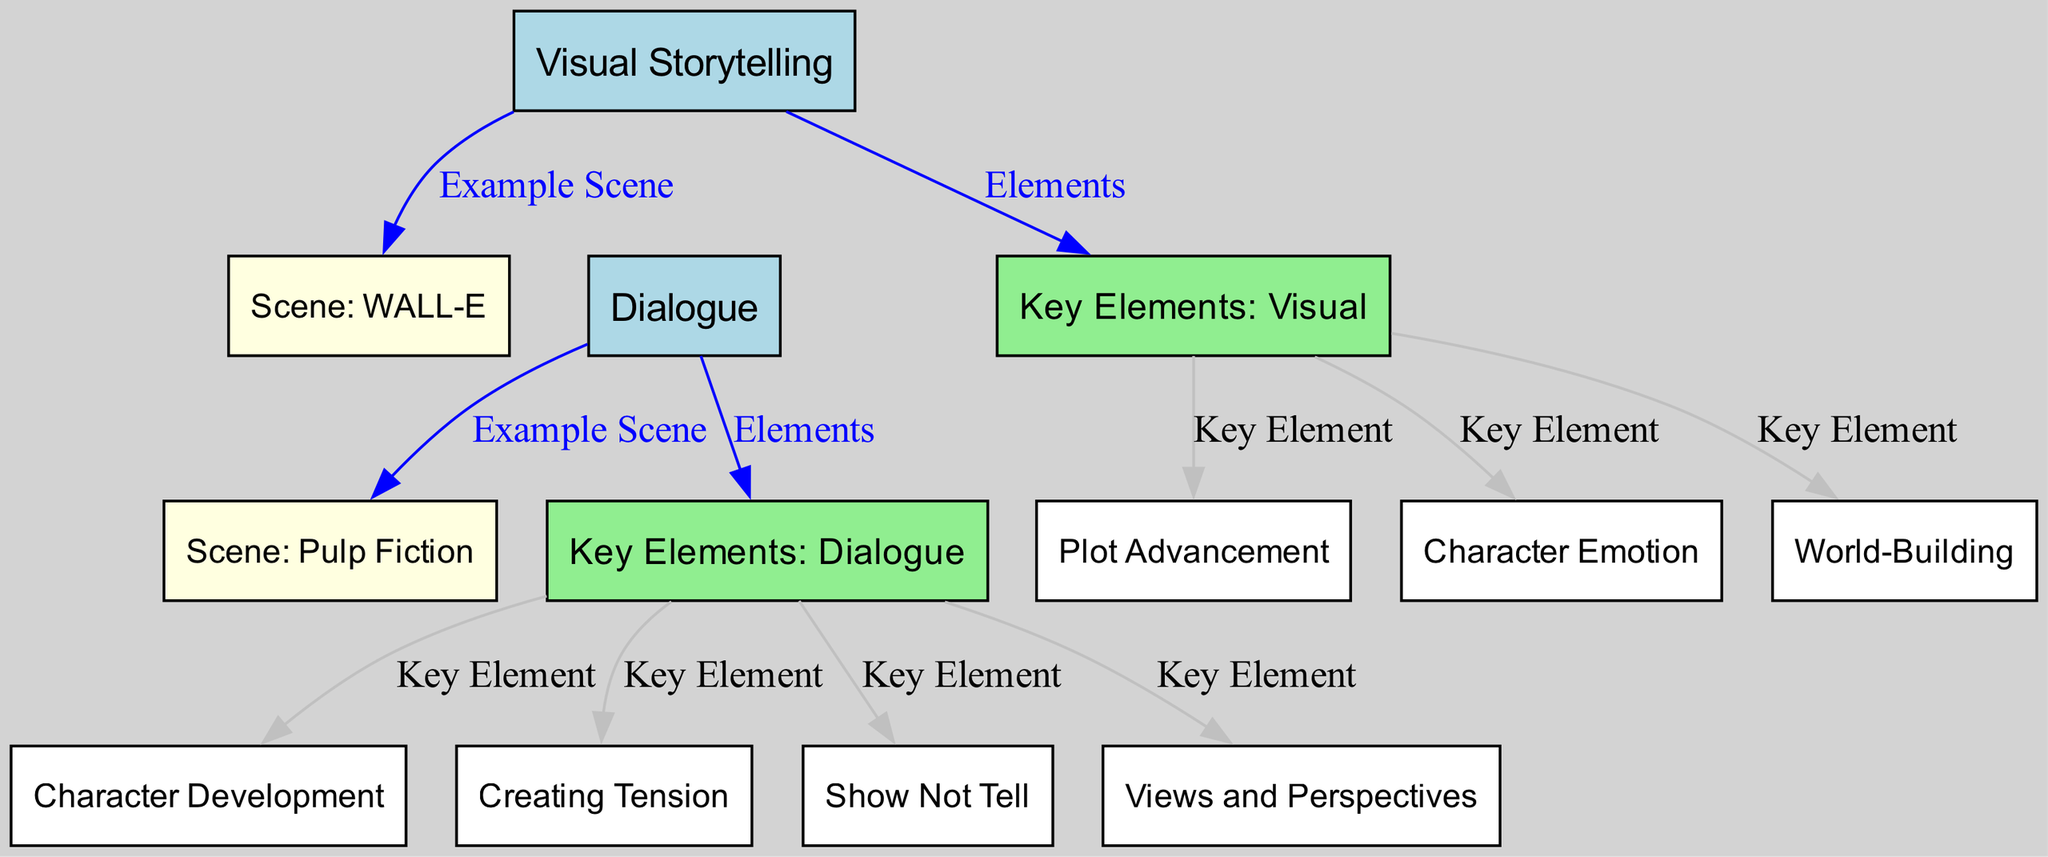what is the main topic of the diagram? The title "Dialogue vs. Visual Storytelling: Effective Use in Screenwriting" indicates the main topic is comparing the use of dialogue and visual storytelling in screenwriting.
Answer: Dialogue vs. Visual Storytelling: Effective Use in Screenwriting how many nodes are there in the diagram? By counting each unique labeled item in the 'nodes' section of the data, we find that there are a total of 13 nodes.
Answer: 13 which scene is associated with visual storytelling? The edge connecting the 'Visual Storytelling' node to the 'Scene: WALL-E' node indicates that WALL-E is an example of visual storytelling in the diagram.
Answer: Scene: WALL-E which scene is associated with dialogue? The edge from the 'Dialogue' node to the 'Scene: Pulp Fiction' node indicates that Pulp Fiction exemplifies the use of dialogue in storytelling.
Answer: Scene: Pulp Fiction what are the three key elements of visual storytelling? The diagram lists 'Character Emotion', 'World-Building', and 'Plot Advancement' as the three key elements connected to the 'Visual' node.
Answer: Character Emotion, World-Building, Plot Advancement what are the four key elements of dialogue? The edges leading from the 'Dialogue' node connect to 'Character Development', 'Creating Tension', 'Show Not Tell', and 'Views and Perspectives', indicating these are the key elements of dialogue.
Answer: Character Development, Creating Tension, Show Not Tell, Views and Perspectives what is the relationship between visual storytelling and character emotion? The edge labeled 'Key Element' connecting 'Visual Storytelling' to 'Character Emotion' suggests that character emotion is an element defined by visual storytelling, reinforcing how visuals can depict character feelings without dialogue.
Answer: Key Element which node connects directly to both visual storytelling and dialogue? The diagram outlines that there is no direct connection from 'Visual Storytelling' to 'Dialogue', but they are linked through the 'Scene: WALL-E' and 'Scene: Pulp Fiction' nodes respectively, which exemplify each method.
Answer: None how does visual storytelling affect plot advancement? The connecting edge labeled 'Key Element' from 'Visual' to 'Plot Advancement' signifies that visual storytelling can effectively push the story forward without relying on dialogue.
Answer: Key Element what is the purpose of using both methods in screenwriting according to the diagram? The diagram implies that combining visual storytelling and dialogue enriches the storytelling experience and enhances immersion by allowing filmmakers to choose the most effective way to convey their narrative.
Answer: Enriching storytelling and enhancing immersion 